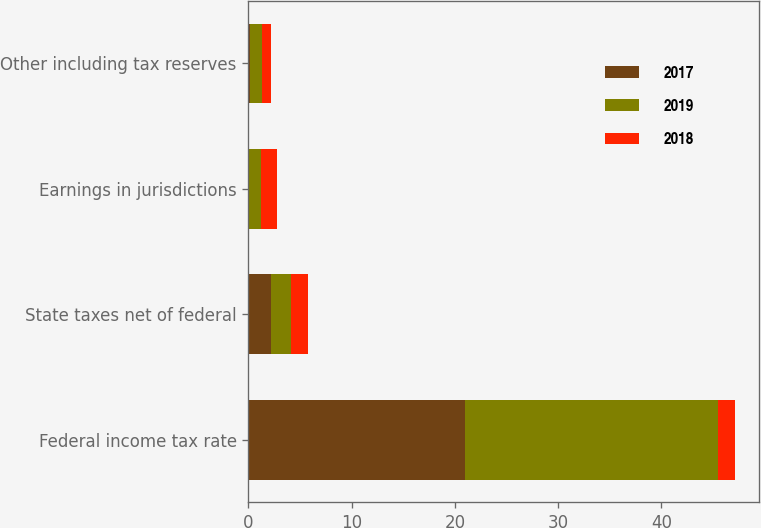Convert chart to OTSL. <chart><loc_0><loc_0><loc_500><loc_500><stacked_bar_chart><ecel><fcel>Federal income tax rate<fcel>State taxes net of federal<fcel>Earnings in jurisdictions<fcel>Other including tax reserves<nl><fcel>2017<fcel>21<fcel>2.2<fcel>0.1<fcel>0.2<nl><fcel>2019<fcel>24.5<fcel>1.9<fcel>1.1<fcel>1.1<nl><fcel>2018<fcel>1.6<fcel>1.7<fcel>1.6<fcel>0.9<nl></chart> 